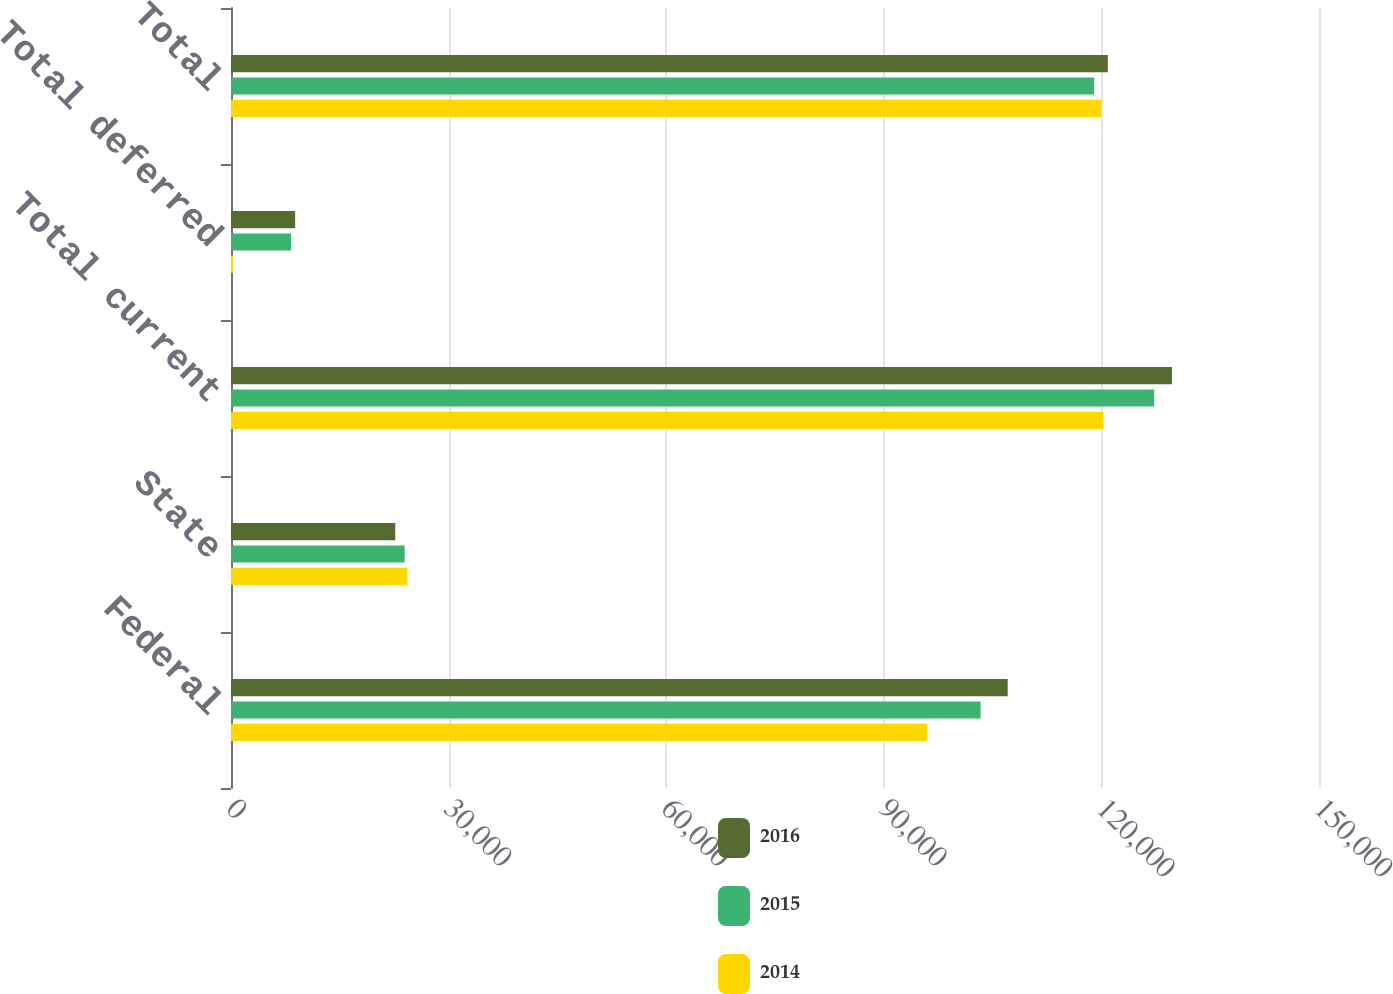<chart> <loc_0><loc_0><loc_500><loc_500><stacked_bar_chart><ecel><fcel>Federal<fcel>State<fcel>Total current<fcel>Total deferred<fcel>Total<nl><fcel>2016<fcel>107083<fcel>22646<fcel>129729<fcel>8845<fcel>120884<nl><fcel>2015<fcel>103344<fcel>23939<fcel>127283<fcel>8282<fcel>119001<nl><fcel>2014<fcel>95946<fcel>24327<fcel>120273<fcel>290<fcel>119983<nl></chart> 